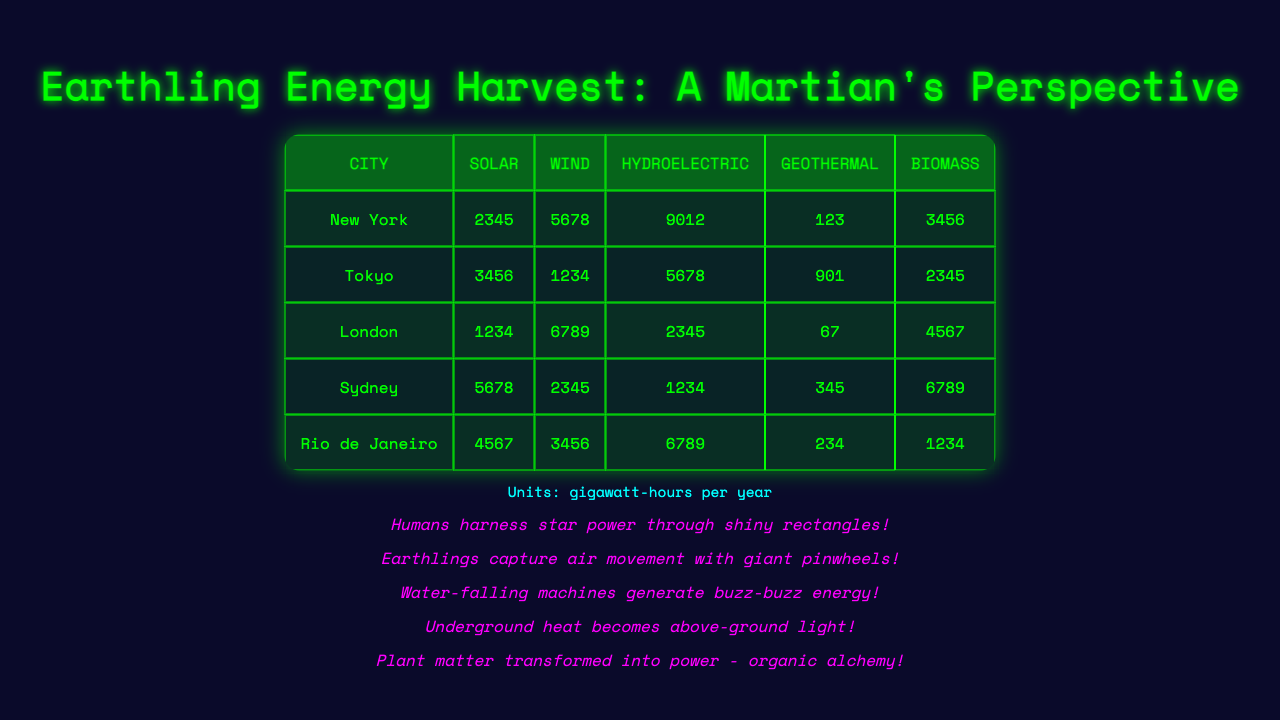What is the total energy consumption from Solar energy in New York? According to the table, New York has 2345 gigawatt-hours per year of Solar energy consumption.
Answer: 2345 Which city has the highest combination of all energy sources? To find this, sum the energy consumption of each source for all cities: New York (2345 + 5678 + 9012 + 123 + 3456), Tokyo (3456 + 1234 + 5678 + 901 + 2345), London (1234 + 6789 + 2345 + 67 + 4567), Sydney (5678 + 2345 + 1234 + 345 + 6789), Rio de Janeiro (4567 + 3456 + 6789 + 234 + 1234). The highest total is found to be New York with 20114.
Answer: New York How much Hydroelectric energy does Rio de Janeiro use? The table shows that Rio de Janeiro uses 6789 gigawatt-hours per year of Hydroelectric energy.
Answer: 6789 Does Tokyo use more Wind energy than Biomass energy? From the table, Tokyo consumes 1234 gigawatt-hours per year of Wind energy and 2345 gigawatt-hours of Biomass. Since 1234 is less than 2345, the answer is no.
Answer: No What is the average consumption of Geothermal energy across all cities? To calculate the average, add together the Geothermal energy values: New York (123) + Tokyo (901) + London (67) + Sydney (345) + Rio de Janeiro (234) = 1670. Then divide by the number of cities (5): 1670 / 5 = 334.
Answer: 334 Which city's Solar energy consumption is closest to the Renewable energy consumption of Biomass in London? London consumes 4567 gigawatt-hours per year of Biomass energy. The Solar energy consumptions for cities are: New York (2345), Tokyo (3456), London (1234), Sydney (5678), and Rio de Janeiro (4567). The closest to 4567 is Rio de Janeiro, which has 4567 gigawatt-hours of Solar energy, it matches perfectly.
Answer: Rio de Janeiro Is the total consumption of Hydroelectric energy in Sydney higher than that of Solar energy in London? Sydney consumes 1234 gigawatt-hours of Hydroelectric energy and London consumes 1234 gigawatt-hours of Solar energy. Since both are equal, the answer is no.
Answer: No If we combine the Wind energy from New York and Sydney, how much energy does that yield? New York has 5678 gigawatt-hours of Wind energy, and Sydney has 2345 gigawatt-hours. Adding these together results in 5678 + 2345 = 8023 gigawatt-hours.
Answer: 8023 Identify the city with the least amount of Geothermal energy consumption. The values for Geothermal energy are: New York (123), Tokyo (901), London (67), Sydney (345), and Rio de Janeiro (234). The least value is 67 from London.
Answer: London How would the energy consumption from Biomass in Sydney compare to the total consumption of Solar energy in New York and Wind energy in Tokyo? Sydney consumes 6789 gigawatt-hours of Biomass. The sum of Solar in New York (2345) and Wind in Tokyo (1234) is 2345 + 1234 = 3579, which is less than 6789. Therefore, Biomass in Sydney exceeds the combined consumption.
Answer: Biomass in Sydney exceeds the combined consumption 